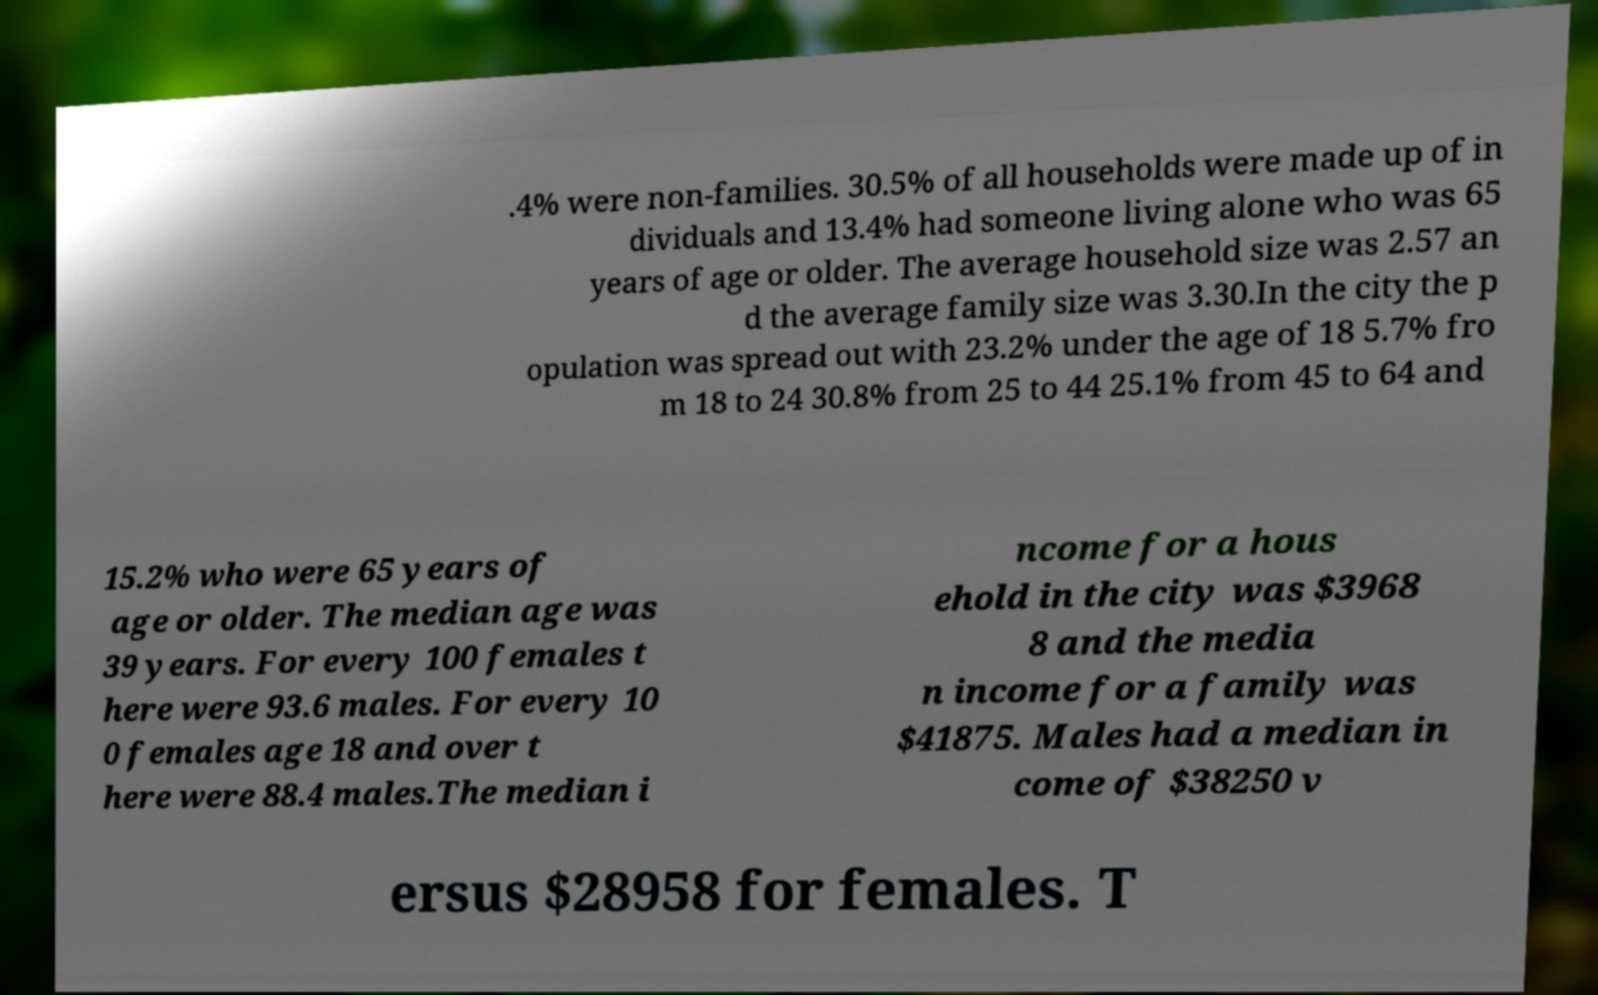For documentation purposes, I need the text within this image transcribed. Could you provide that? .4% were non-families. 30.5% of all households were made up of in dividuals and 13.4% had someone living alone who was 65 years of age or older. The average household size was 2.57 an d the average family size was 3.30.In the city the p opulation was spread out with 23.2% under the age of 18 5.7% fro m 18 to 24 30.8% from 25 to 44 25.1% from 45 to 64 and 15.2% who were 65 years of age or older. The median age was 39 years. For every 100 females t here were 93.6 males. For every 10 0 females age 18 and over t here were 88.4 males.The median i ncome for a hous ehold in the city was $3968 8 and the media n income for a family was $41875. Males had a median in come of $38250 v ersus $28958 for females. T 